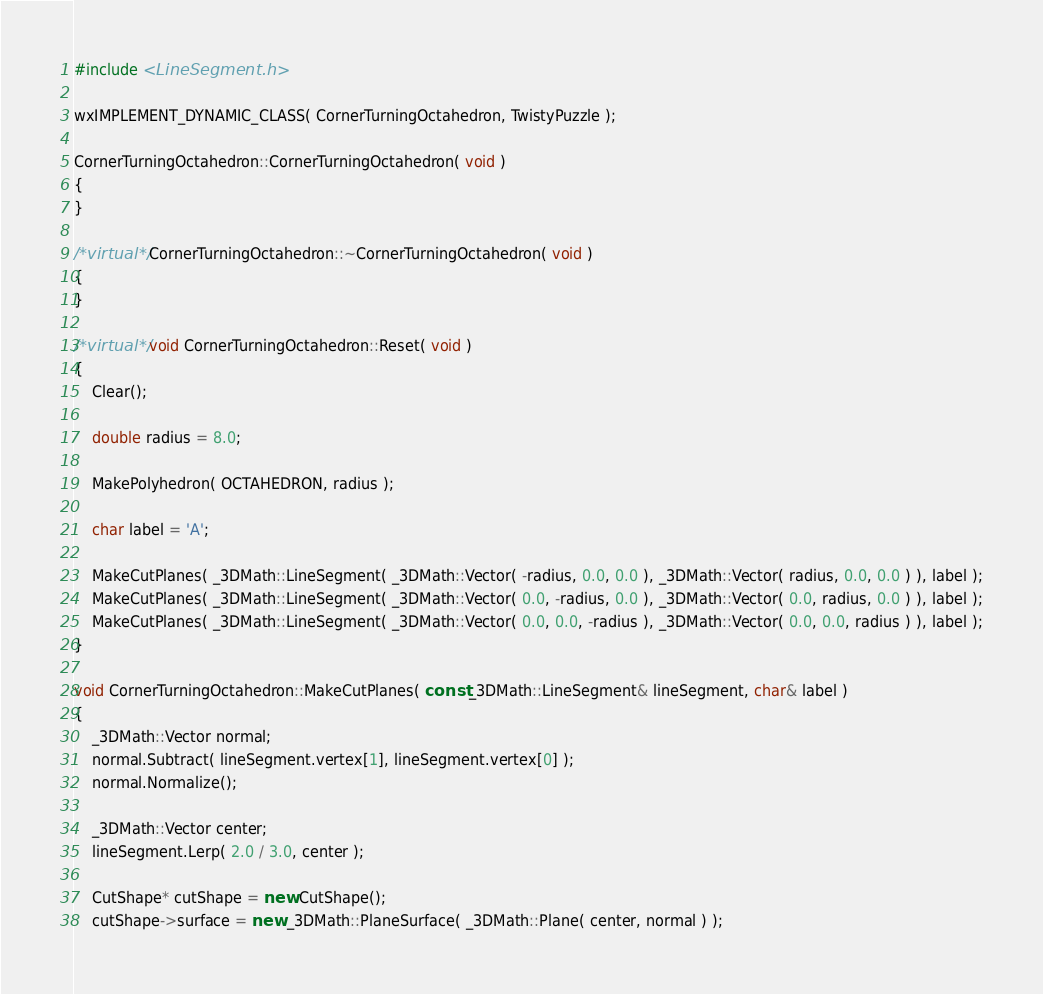<code> <loc_0><loc_0><loc_500><loc_500><_C++_>#include <LineSegment.h>

wxIMPLEMENT_DYNAMIC_CLASS( CornerTurningOctahedron, TwistyPuzzle );

CornerTurningOctahedron::CornerTurningOctahedron( void )
{
}

/*virtual*/ CornerTurningOctahedron::~CornerTurningOctahedron( void )
{
}

/*virtual*/ void CornerTurningOctahedron::Reset( void )
{
	Clear();

	double radius = 8.0;

	MakePolyhedron( OCTAHEDRON, radius );

	char label = 'A';

	MakeCutPlanes( _3DMath::LineSegment( _3DMath::Vector( -radius, 0.0, 0.0 ), _3DMath::Vector( radius, 0.0, 0.0 ) ), label );
	MakeCutPlanes( _3DMath::LineSegment( _3DMath::Vector( 0.0, -radius, 0.0 ), _3DMath::Vector( 0.0, radius, 0.0 ) ), label );
	MakeCutPlanes( _3DMath::LineSegment( _3DMath::Vector( 0.0, 0.0, -radius ), _3DMath::Vector( 0.0, 0.0, radius ) ), label );
}

void CornerTurningOctahedron::MakeCutPlanes( const _3DMath::LineSegment& lineSegment, char& label )
{
	_3DMath::Vector normal;
	normal.Subtract( lineSegment.vertex[1], lineSegment.vertex[0] );
	normal.Normalize();

	_3DMath::Vector center;
	lineSegment.Lerp( 2.0 / 3.0, center );

	CutShape* cutShape = new CutShape();
	cutShape->surface = new _3DMath::PlaneSurface( _3DMath::Plane( center, normal ) );</code> 